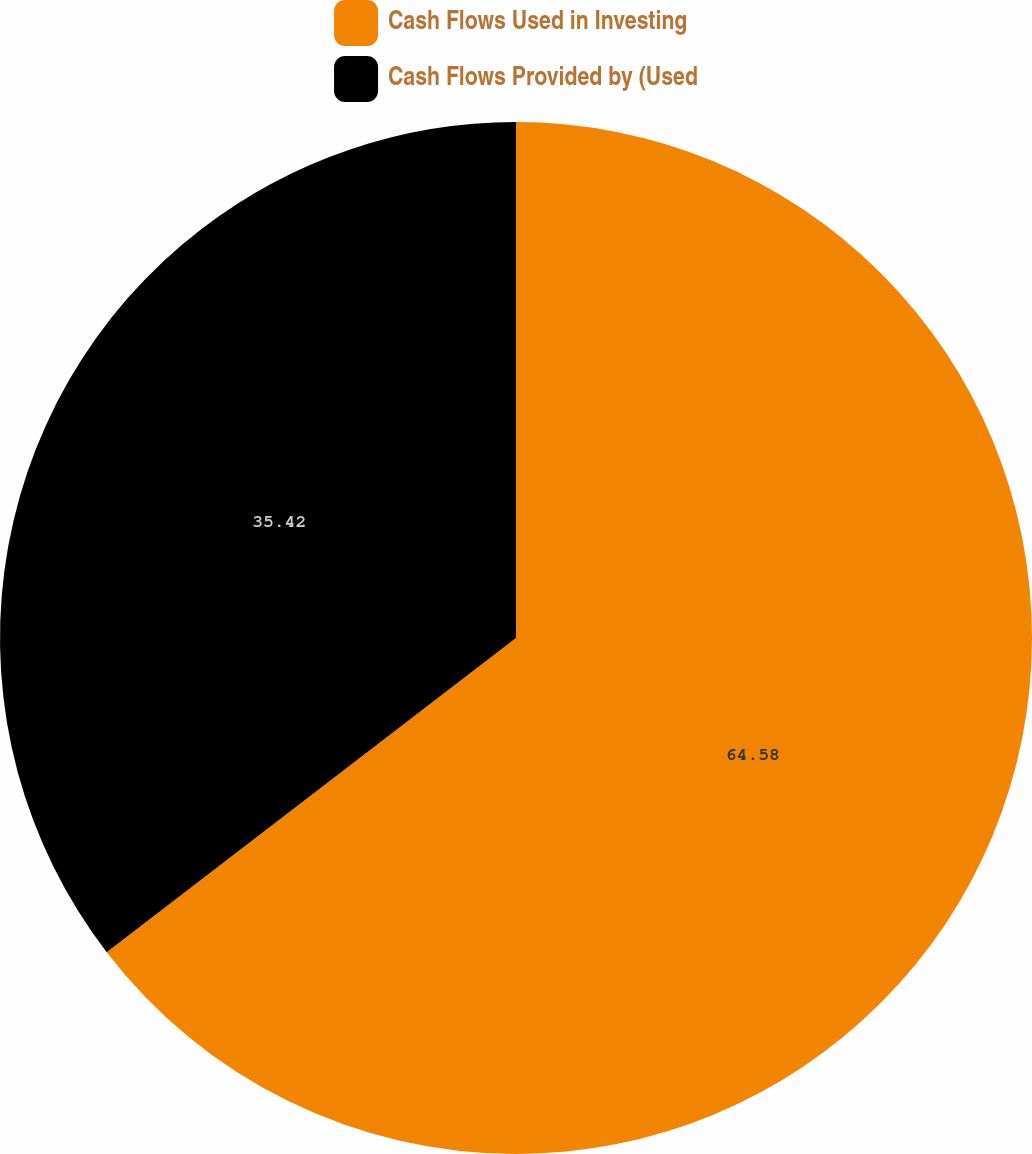Convert chart to OTSL. <chart><loc_0><loc_0><loc_500><loc_500><pie_chart><fcel>Cash Flows Used in Investing<fcel>Cash Flows Provided by (Used<nl><fcel>64.58%<fcel>35.42%<nl></chart> 